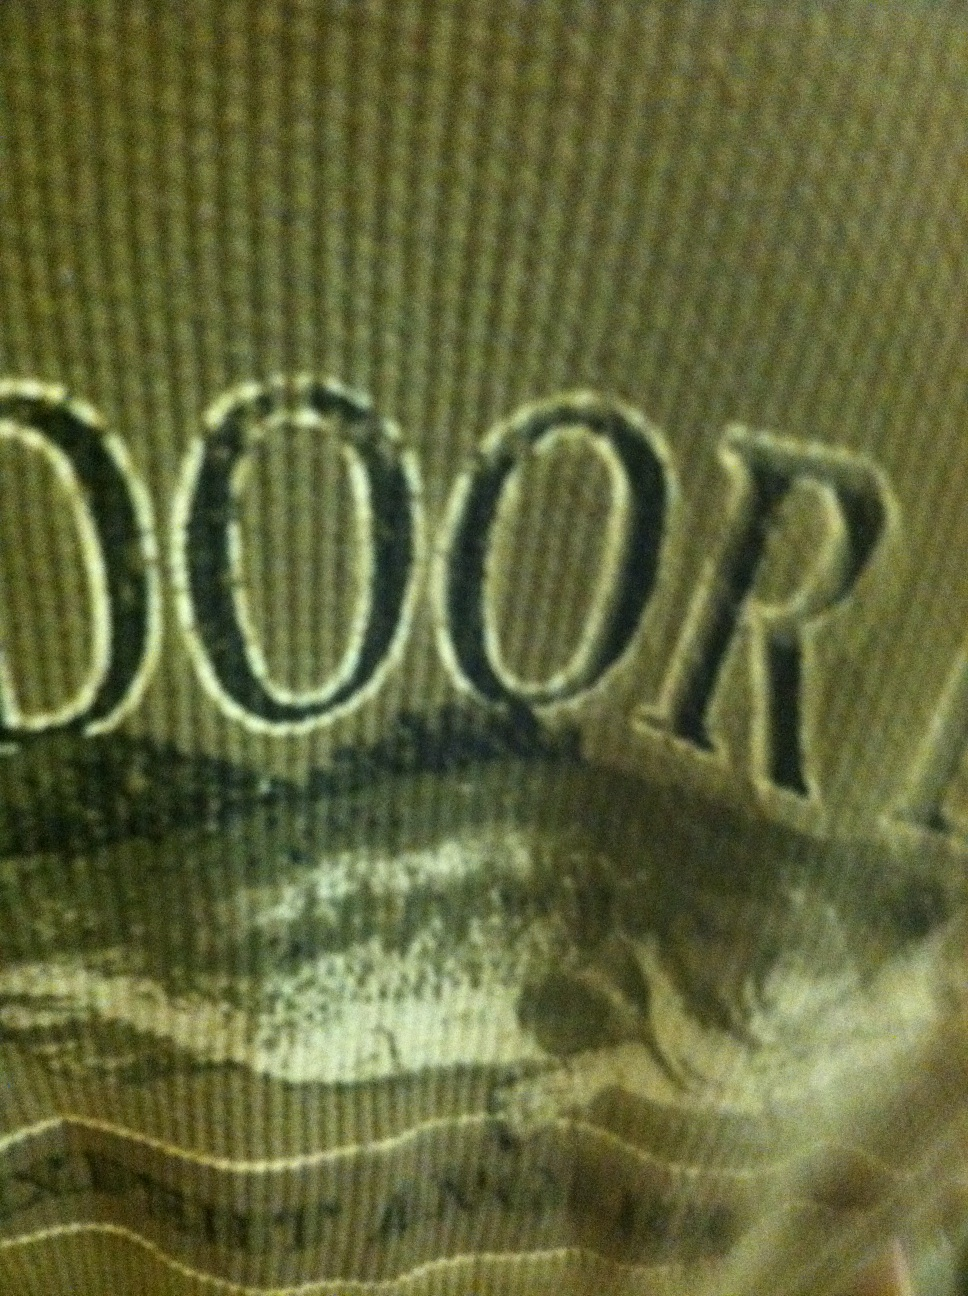Can you create a detailed and adventurous scenario involving this shirt? Imagine wearing this green 'OUTDOOR' shirt on a multi-day trekking expedition in the Rocky Mountains. The days are filled with breathtaking vistas of snow-capped peaks, dense pine forests, and crystal-clear alpine lakes. Each morning, the shirt is pulled on as you set out at dawn, the cool morning air invigorating your senses. As you hike through challenging trails, the shirt wicks away sweat, keeping you comfortable. Evenings around the campfire are the highlight of the day, sharing stories with fellow hikers, the flames reflecting in their eyes, with your dependable green shirt a silent witness to the camaraderie and adventure. Through rain and shine, ascents and descents, the shirt stays with you, a reliable companion in the wild. 